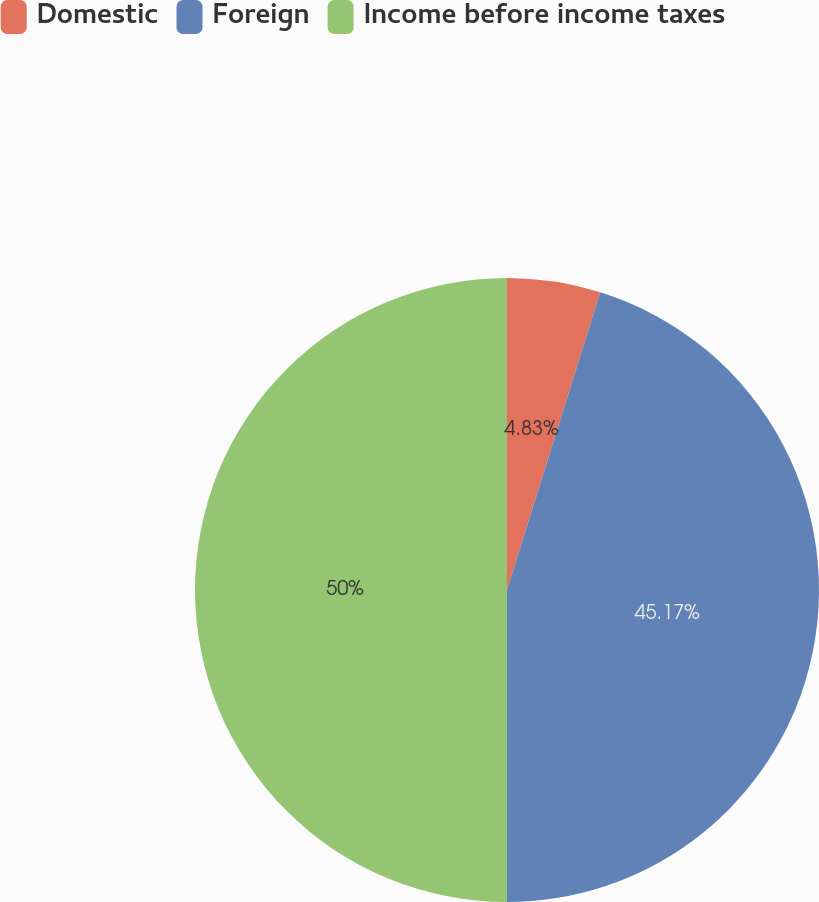Convert chart. <chart><loc_0><loc_0><loc_500><loc_500><pie_chart><fcel>Domestic<fcel>Foreign<fcel>Income before income taxes<nl><fcel>4.83%<fcel>45.17%<fcel>50.0%<nl></chart> 